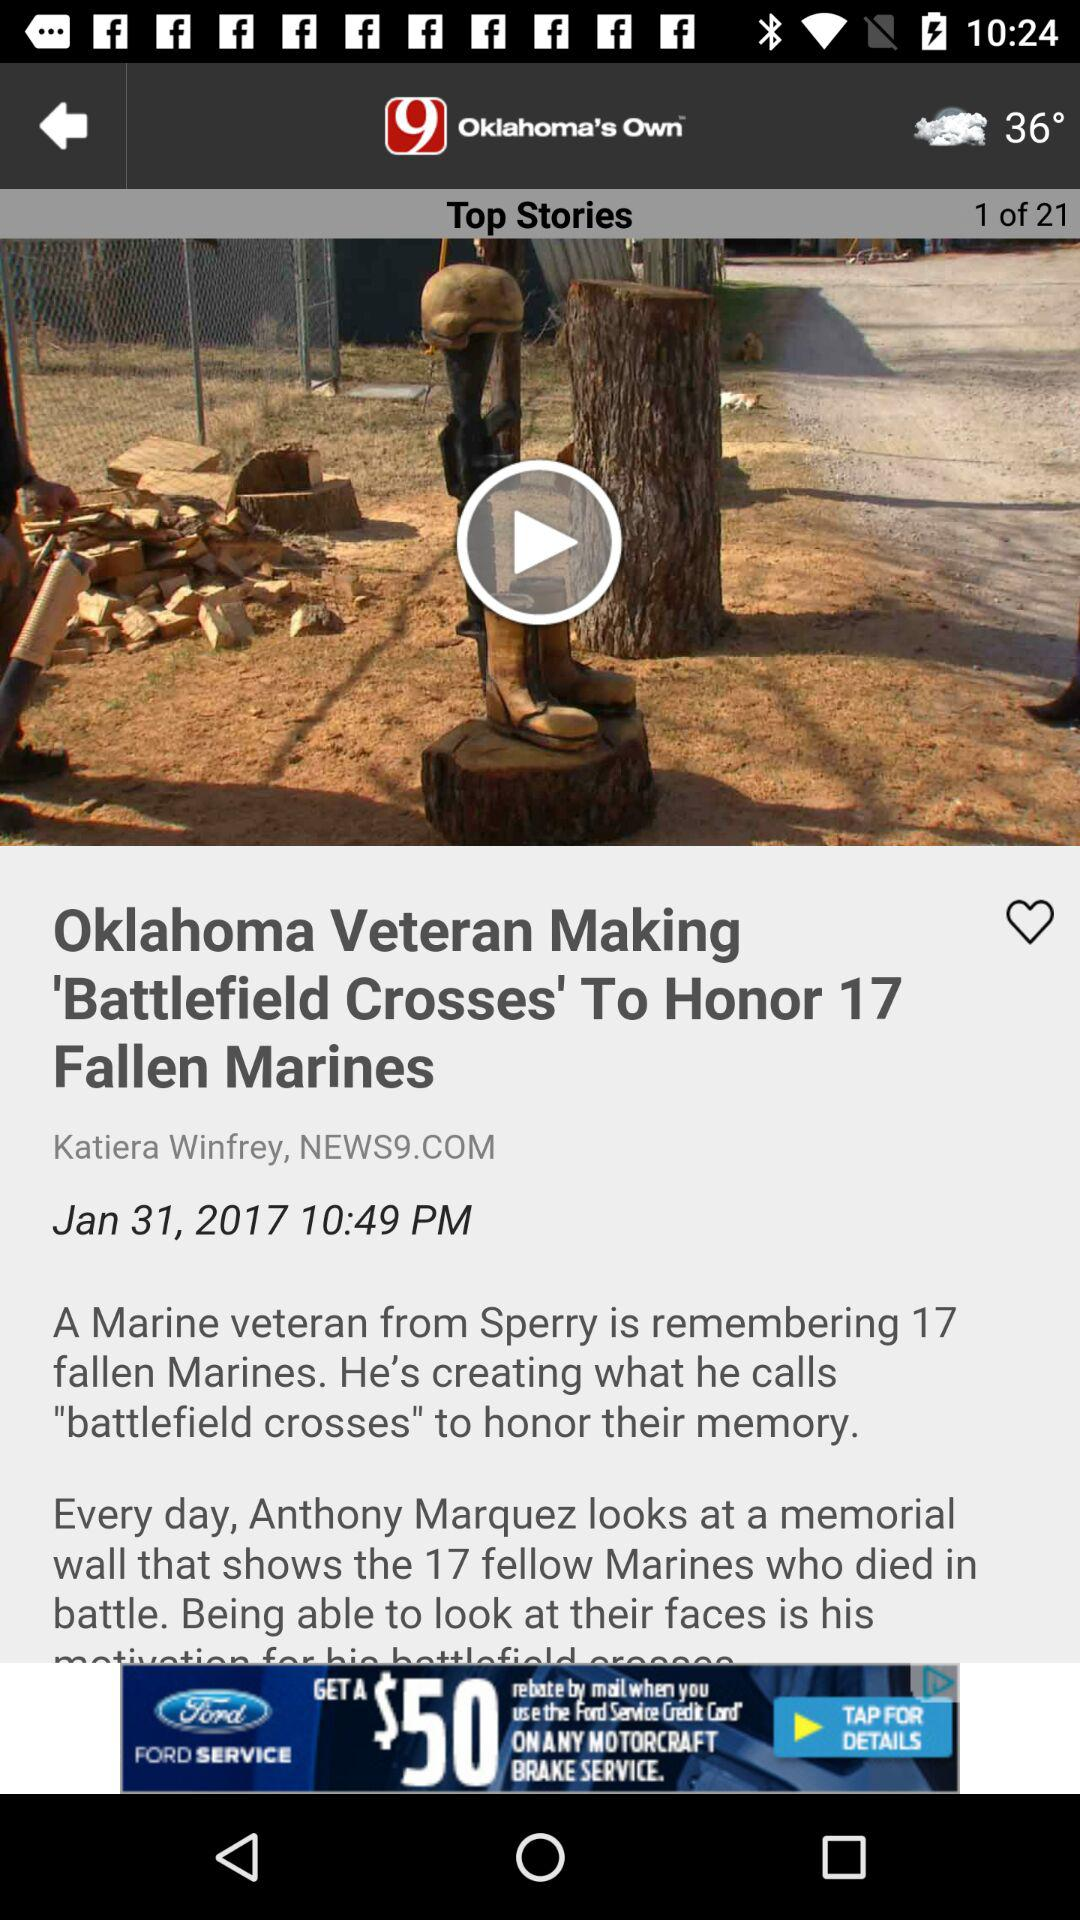What is the temperature? The temperature is 36°. 